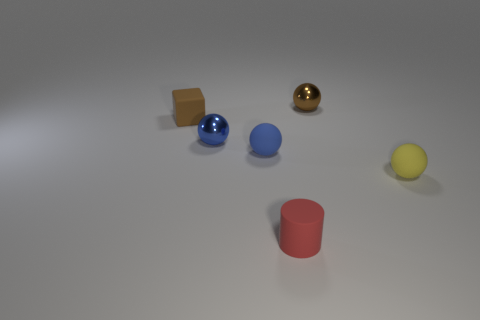Is the number of brown metallic spheres that are left of the small brown sphere greater than the number of brown rubber objects that are in front of the tiny brown rubber cube?
Provide a short and direct response. No. How many other things are there of the same size as the brown matte object?
Provide a short and direct response. 5. What is the size of the metal object that is the same color as the small block?
Offer a terse response. Small. What material is the thing behind the brown object left of the red matte cylinder made of?
Provide a short and direct response. Metal. Are there any small shiny balls on the right side of the red cylinder?
Provide a short and direct response. Yes. Are there more tiny brown things in front of the block than small brown spheres?
Offer a terse response. No. Are there any objects of the same color as the small cube?
Make the answer very short. Yes. What is the color of the cylinder that is the same size as the matte block?
Offer a terse response. Red. Are there any brown metal things that are to the right of the small thing that is behind the small block?
Your response must be concise. No. There is a small sphere that is behind the small brown cube; what material is it?
Your response must be concise. Metal. 